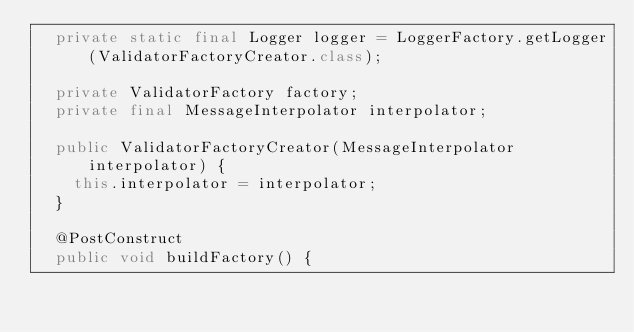<code> <loc_0><loc_0><loc_500><loc_500><_Java_>	private static final Logger logger = LoggerFactory.getLogger(ValidatorFactoryCreator.class);

	private ValidatorFactory factory;
	private final MessageInterpolator interpolator;

	public ValidatorFactoryCreator(MessageInterpolator interpolator) {
		this.interpolator = interpolator;
	}

	@PostConstruct
	public void buildFactory() {</code> 